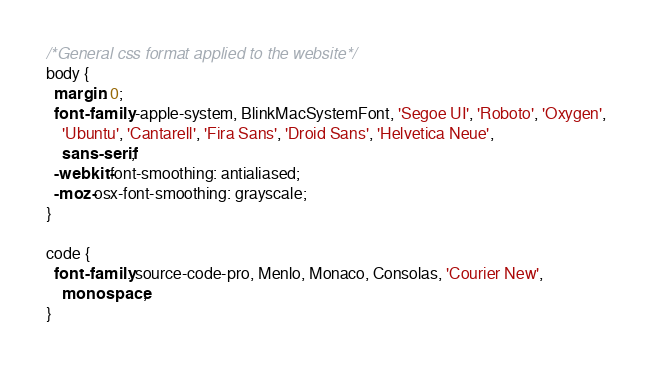Convert code to text. <code><loc_0><loc_0><loc_500><loc_500><_CSS_>/*General css format applied to the website*/
body {
  margin: 0;
  font-family: -apple-system, BlinkMacSystemFont, 'Segoe UI', 'Roboto', 'Oxygen',
    'Ubuntu', 'Cantarell', 'Fira Sans', 'Droid Sans', 'Helvetica Neue',
    sans-serif;
  -webkit-font-smoothing: antialiased;
  -moz-osx-font-smoothing: grayscale;
}

code {
  font-family: source-code-pro, Menlo, Monaco, Consolas, 'Courier New',
    monospace;
}
</code> 